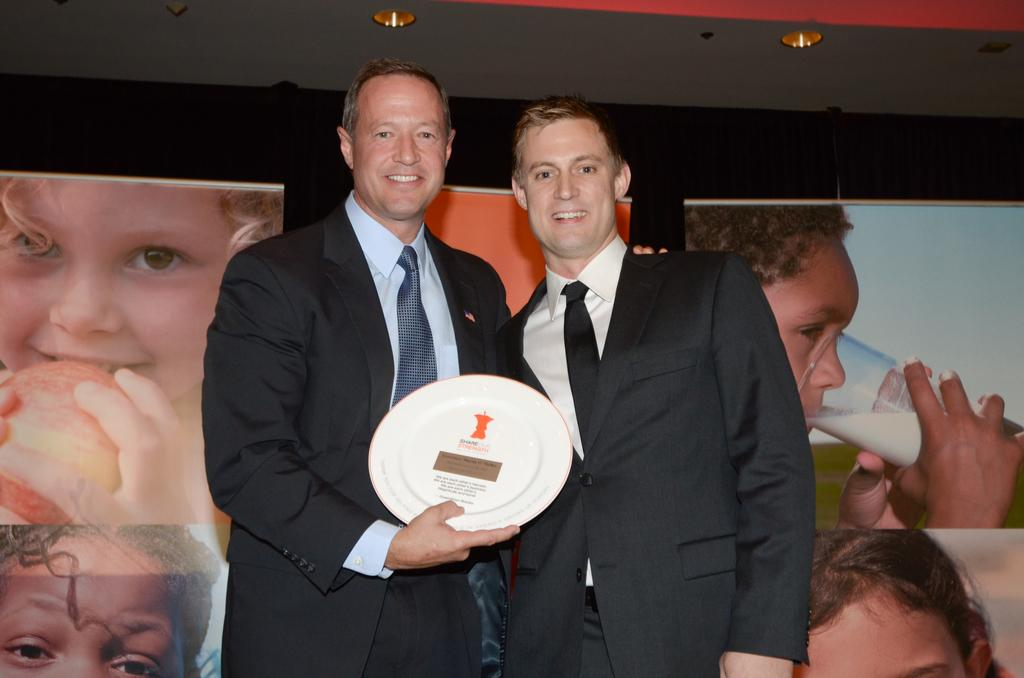How many people are in the image? There are two persons standing in the center of the image. What can be seen in the background of the image? There are posters, a wall, and lights in the background of the image. What color is the orange being held by the team in the image? There is no orange or team present in the image. How many volleyballs are visible in the image? There are no volleyballs visible in the image. 